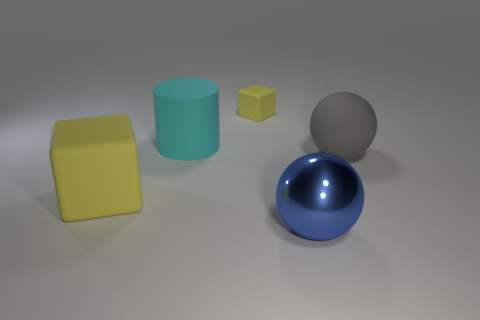Add 2 tiny blue rubber spheres. How many objects exist? 7 Subtract all balls. How many objects are left? 3 Add 2 large cyan shiny things. How many large cyan shiny things exist? 2 Subtract 0 brown spheres. How many objects are left? 5 Subtract all small gray rubber cubes. Subtract all small rubber cubes. How many objects are left? 4 Add 4 cyan cylinders. How many cyan cylinders are left? 5 